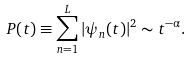<formula> <loc_0><loc_0><loc_500><loc_500>P ( t ) \equiv \sum _ { n = 1 } ^ { L } | \psi _ { n } ( t ) | ^ { 2 } \sim t ^ { - \alpha } .</formula> 